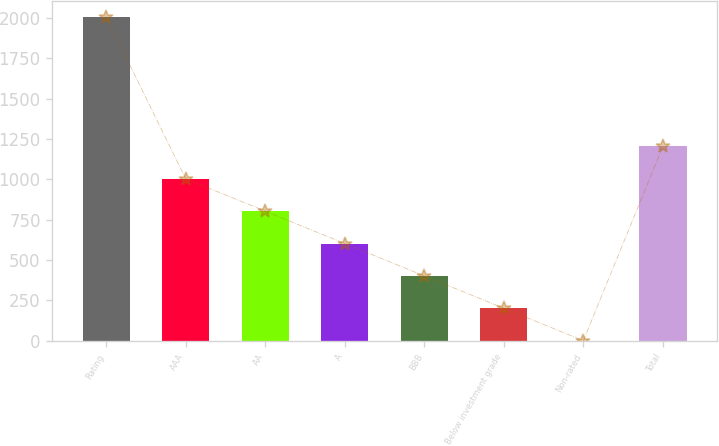Convert chart. <chart><loc_0><loc_0><loc_500><loc_500><bar_chart><fcel>Rating<fcel>AAA<fcel>AA<fcel>A<fcel>BBB<fcel>Below investment grade<fcel>Non-rated<fcel>Total<nl><fcel>2007<fcel>1004<fcel>803.4<fcel>602.8<fcel>402.2<fcel>201.6<fcel>1<fcel>1204.6<nl></chart> 